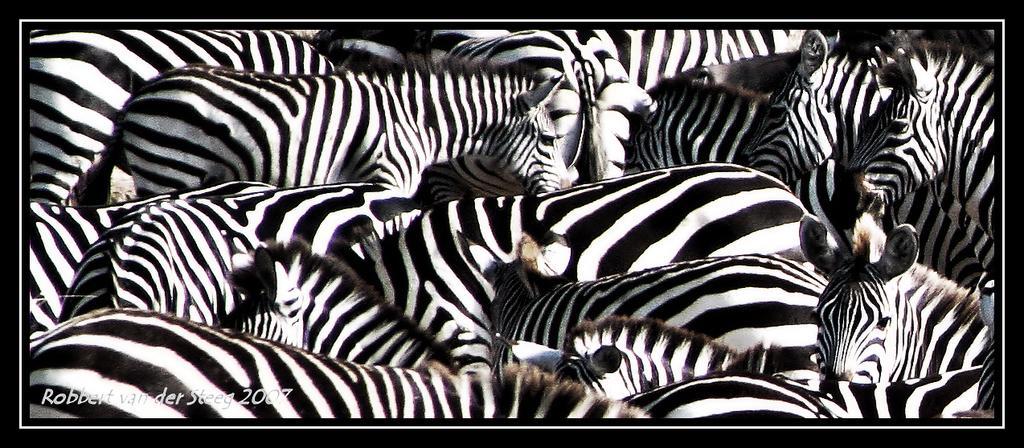In one or two sentences, can you explain what this image depicts? In this picture we can see a few zebras, some text and numbers in the bottom left. 